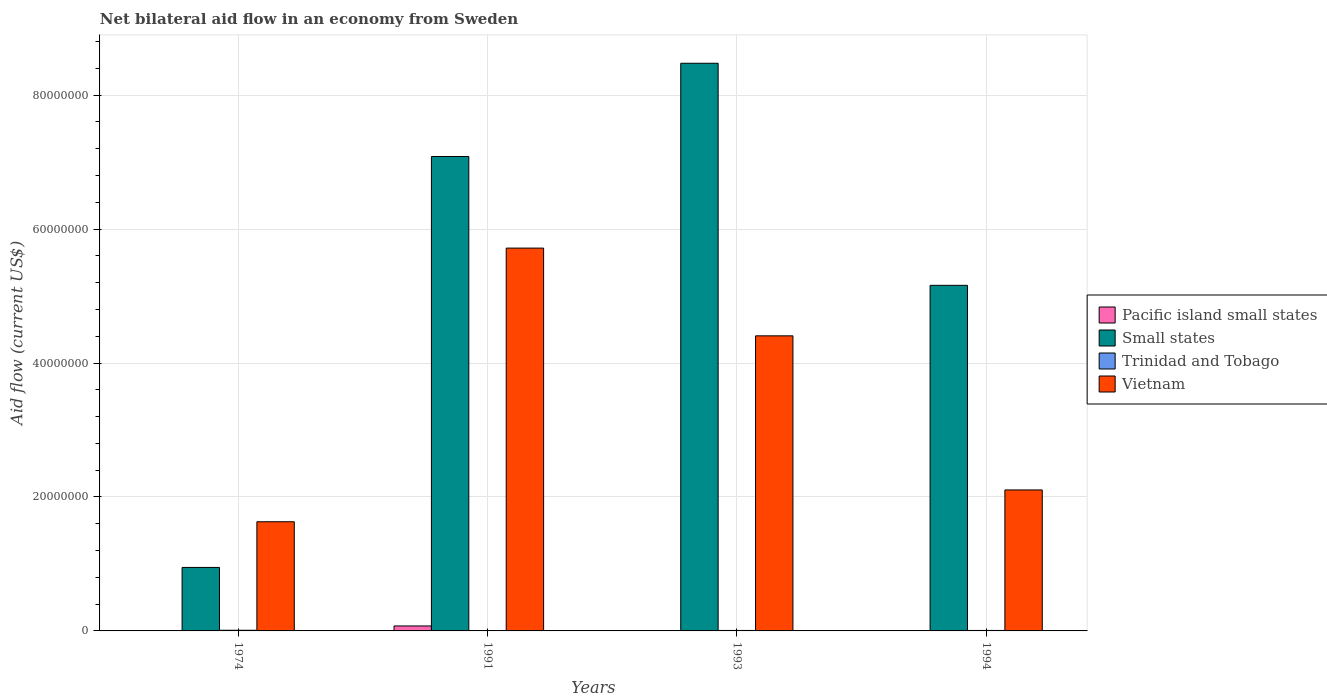How many groups of bars are there?
Your response must be concise. 4. How many bars are there on the 3rd tick from the left?
Your response must be concise. 4. What is the label of the 4th group of bars from the left?
Your answer should be very brief. 1994. Across all years, what is the maximum net bilateral aid flow in Small states?
Keep it short and to the point. 8.48e+07. Across all years, what is the minimum net bilateral aid flow in Pacific island small states?
Give a very brief answer. 2.00e+04. In which year was the net bilateral aid flow in Small states minimum?
Keep it short and to the point. 1974. What is the total net bilateral aid flow in Pacific island small states in the graph?
Ensure brevity in your answer.  8.50e+05. What is the difference between the net bilateral aid flow in Vietnam in 1974 and that in 1991?
Provide a short and direct response. -4.09e+07. What is the difference between the net bilateral aid flow in Small states in 1993 and the net bilateral aid flow in Vietnam in 1991?
Provide a short and direct response. 2.76e+07. What is the average net bilateral aid flow in Vietnam per year?
Ensure brevity in your answer.  3.46e+07. In the year 1974, what is the difference between the net bilateral aid flow in Pacific island small states and net bilateral aid flow in Trinidad and Tobago?
Give a very brief answer. -6.00e+04. What is the ratio of the net bilateral aid flow in Vietnam in 1991 to that in 1993?
Provide a short and direct response. 1.3. Is the net bilateral aid flow in Pacific island small states in 1991 less than that in 1993?
Keep it short and to the point. No. What is the difference between the highest and the second highest net bilateral aid flow in Pacific island small states?
Make the answer very short. 6.90e+05. What is the difference between the highest and the lowest net bilateral aid flow in Pacific island small states?
Your answer should be compact. 7.20e+05. What does the 1st bar from the left in 1974 represents?
Offer a very short reply. Pacific island small states. What does the 1st bar from the right in 1991 represents?
Offer a terse response. Vietnam. Is it the case that in every year, the sum of the net bilateral aid flow in Small states and net bilateral aid flow in Pacific island small states is greater than the net bilateral aid flow in Vietnam?
Offer a terse response. No. Are all the bars in the graph horizontal?
Keep it short and to the point. No. What is the difference between two consecutive major ticks on the Y-axis?
Provide a succinct answer. 2.00e+07. Are the values on the major ticks of Y-axis written in scientific E-notation?
Offer a very short reply. No. How many legend labels are there?
Ensure brevity in your answer.  4. What is the title of the graph?
Give a very brief answer. Net bilateral aid flow in an economy from Sweden. What is the label or title of the X-axis?
Offer a very short reply. Years. What is the Aid flow (current US$) of Pacific island small states in 1974?
Make the answer very short. 4.00e+04. What is the Aid flow (current US$) of Small states in 1974?
Your answer should be compact. 9.48e+06. What is the Aid flow (current US$) of Vietnam in 1974?
Keep it short and to the point. 1.63e+07. What is the Aid flow (current US$) of Pacific island small states in 1991?
Keep it short and to the point. 7.40e+05. What is the Aid flow (current US$) of Small states in 1991?
Give a very brief answer. 7.08e+07. What is the Aid flow (current US$) of Trinidad and Tobago in 1991?
Make the answer very short. 3.00e+04. What is the Aid flow (current US$) of Vietnam in 1991?
Your answer should be very brief. 5.72e+07. What is the Aid flow (current US$) of Pacific island small states in 1993?
Your answer should be compact. 5.00e+04. What is the Aid flow (current US$) of Small states in 1993?
Your answer should be compact. 8.48e+07. What is the Aid flow (current US$) in Trinidad and Tobago in 1993?
Your answer should be compact. 7.00e+04. What is the Aid flow (current US$) in Vietnam in 1993?
Keep it short and to the point. 4.41e+07. What is the Aid flow (current US$) of Small states in 1994?
Your response must be concise. 5.16e+07. What is the Aid flow (current US$) of Trinidad and Tobago in 1994?
Offer a very short reply. 7.00e+04. What is the Aid flow (current US$) in Vietnam in 1994?
Offer a terse response. 2.10e+07. Across all years, what is the maximum Aid flow (current US$) of Pacific island small states?
Offer a terse response. 7.40e+05. Across all years, what is the maximum Aid flow (current US$) in Small states?
Ensure brevity in your answer.  8.48e+07. Across all years, what is the maximum Aid flow (current US$) of Vietnam?
Your answer should be very brief. 5.72e+07. Across all years, what is the minimum Aid flow (current US$) in Small states?
Offer a very short reply. 9.48e+06. Across all years, what is the minimum Aid flow (current US$) of Trinidad and Tobago?
Provide a short and direct response. 3.00e+04. Across all years, what is the minimum Aid flow (current US$) in Vietnam?
Your answer should be very brief. 1.63e+07. What is the total Aid flow (current US$) in Pacific island small states in the graph?
Give a very brief answer. 8.50e+05. What is the total Aid flow (current US$) in Small states in the graph?
Provide a succinct answer. 2.17e+08. What is the total Aid flow (current US$) in Trinidad and Tobago in the graph?
Your response must be concise. 2.70e+05. What is the total Aid flow (current US$) in Vietnam in the graph?
Ensure brevity in your answer.  1.39e+08. What is the difference between the Aid flow (current US$) of Pacific island small states in 1974 and that in 1991?
Your answer should be compact. -7.00e+05. What is the difference between the Aid flow (current US$) of Small states in 1974 and that in 1991?
Provide a succinct answer. -6.14e+07. What is the difference between the Aid flow (current US$) in Vietnam in 1974 and that in 1991?
Provide a short and direct response. -4.09e+07. What is the difference between the Aid flow (current US$) of Small states in 1974 and that in 1993?
Provide a succinct answer. -7.53e+07. What is the difference between the Aid flow (current US$) of Vietnam in 1974 and that in 1993?
Make the answer very short. -2.78e+07. What is the difference between the Aid flow (current US$) in Small states in 1974 and that in 1994?
Your answer should be very brief. -4.21e+07. What is the difference between the Aid flow (current US$) of Vietnam in 1974 and that in 1994?
Give a very brief answer. -4.75e+06. What is the difference between the Aid flow (current US$) of Pacific island small states in 1991 and that in 1993?
Your response must be concise. 6.90e+05. What is the difference between the Aid flow (current US$) in Small states in 1991 and that in 1993?
Provide a short and direct response. -1.39e+07. What is the difference between the Aid flow (current US$) of Trinidad and Tobago in 1991 and that in 1993?
Provide a succinct answer. -4.00e+04. What is the difference between the Aid flow (current US$) of Vietnam in 1991 and that in 1993?
Your response must be concise. 1.31e+07. What is the difference between the Aid flow (current US$) in Pacific island small states in 1991 and that in 1994?
Provide a short and direct response. 7.20e+05. What is the difference between the Aid flow (current US$) in Small states in 1991 and that in 1994?
Make the answer very short. 1.92e+07. What is the difference between the Aid flow (current US$) of Vietnam in 1991 and that in 1994?
Provide a short and direct response. 3.61e+07. What is the difference between the Aid flow (current US$) in Small states in 1993 and that in 1994?
Provide a succinct answer. 3.32e+07. What is the difference between the Aid flow (current US$) in Vietnam in 1993 and that in 1994?
Your answer should be very brief. 2.30e+07. What is the difference between the Aid flow (current US$) in Pacific island small states in 1974 and the Aid flow (current US$) in Small states in 1991?
Ensure brevity in your answer.  -7.08e+07. What is the difference between the Aid flow (current US$) in Pacific island small states in 1974 and the Aid flow (current US$) in Trinidad and Tobago in 1991?
Offer a very short reply. 10000. What is the difference between the Aid flow (current US$) of Pacific island small states in 1974 and the Aid flow (current US$) of Vietnam in 1991?
Offer a terse response. -5.71e+07. What is the difference between the Aid flow (current US$) in Small states in 1974 and the Aid flow (current US$) in Trinidad and Tobago in 1991?
Ensure brevity in your answer.  9.45e+06. What is the difference between the Aid flow (current US$) of Small states in 1974 and the Aid flow (current US$) of Vietnam in 1991?
Provide a short and direct response. -4.77e+07. What is the difference between the Aid flow (current US$) of Trinidad and Tobago in 1974 and the Aid flow (current US$) of Vietnam in 1991?
Offer a very short reply. -5.71e+07. What is the difference between the Aid flow (current US$) in Pacific island small states in 1974 and the Aid flow (current US$) in Small states in 1993?
Your answer should be very brief. -8.47e+07. What is the difference between the Aid flow (current US$) of Pacific island small states in 1974 and the Aid flow (current US$) of Trinidad and Tobago in 1993?
Keep it short and to the point. -3.00e+04. What is the difference between the Aid flow (current US$) in Pacific island small states in 1974 and the Aid flow (current US$) in Vietnam in 1993?
Your answer should be compact. -4.40e+07. What is the difference between the Aid flow (current US$) of Small states in 1974 and the Aid flow (current US$) of Trinidad and Tobago in 1993?
Keep it short and to the point. 9.41e+06. What is the difference between the Aid flow (current US$) of Small states in 1974 and the Aid flow (current US$) of Vietnam in 1993?
Ensure brevity in your answer.  -3.46e+07. What is the difference between the Aid flow (current US$) of Trinidad and Tobago in 1974 and the Aid flow (current US$) of Vietnam in 1993?
Give a very brief answer. -4.40e+07. What is the difference between the Aid flow (current US$) in Pacific island small states in 1974 and the Aid flow (current US$) in Small states in 1994?
Provide a succinct answer. -5.16e+07. What is the difference between the Aid flow (current US$) in Pacific island small states in 1974 and the Aid flow (current US$) in Vietnam in 1994?
Your answer should be compact. -2.10e+07. What is the difference between the Aid flow (current US$) of Small states in 1974 and the Aid flow (current US$) of Trinidad and Tobago in 1994?
Keep it short and to the point. 9.41e+06. What is the difference between the Aid flow (current US$) of Small states in 1974 and the Aid flow (current US$) of Vietnam in 1994?
Offer a very short reply. -1.16e+07. What is the difference between the Aid flow (current US$) of Trinidad and Tobago in 1974 and the Aid flow (current US$) of Vietnam in 1994?
Keep it short and to the point. -2.10e+07. What is the difference between the Aid flow (current US$) of Pacific island small states in 1991 and the Aid flow (current US$) of Small states in 1993?
Your answer should be very brief. -8.40e+07. What is the difference between the Aid flow (current US$) in Pacific island small states in 1991 and the Aid flow (current US$) in Trinidad and Tobago in 1993?
Provide a succinct answer. 6.70e+05. What is the difference between the Aid flow (current US$) of Pacific island small states in 1991 and the Aid flow (current US$) of Vietnam in 1993?
Ensure brevity in your answer.  -4.33e+07. What is the difference between the Aid flow (current US$) of Small states in 1991 and the Aid flow (current US$) of Trinidad and Tobago in 1993?
Make the answer very short. 7.08e+07. What is the difference between the Aid flow (current US$) in Small states in 1991 and the Aid flow (current US$) in Vietnam in 1993?
Your answer should be compact. 2.68e+07. What is the difference between the Aid flow (current US$) in Trinidad and Tobago in 1991 and the Aid flow (current US$) in Vietnam in 1993?
Your answer should be very brief. -4.40e+07. What is the difference between the Aid flow (current US$) of Pacific island small states in 1991 and the Aid flow (current US$) of Small states in 1994?
Offer a very short reply. -5.09e+07. What is the difference between the Aid flow (current US$) of Pacific island small states in 1991 and the Aid flow (current US$) of Trinidad and Tobago in 1994?
Offer a very short reply. 6.70e+05. What is the difference between the Aid flow (current US$) in Pacific island small states in 1991 and the Aid flow (current US$) in Vietnam in 1994?
Ensure brevity in your answer.  -2.03e+07. What is the difference between the Aid flow (current US$) in Small states in 1991 and the Aid flow (current US$) in Trinidad and Tobago in 1994?
Give a very brief answer. 7.08e+07. What is the difference between the Aid flow (current US$) in Small states in 1991 and the Aid flow (current US$) in Vietnam in 1994?
Make the answer very short. 4.98e+07. What is the difference between the Aid flow (current US$) in Trinidad and Tobago in 1991 and the Aid flow (current US$) in Vietnam in 1994?
Provide a short and direct response. -2.10e+07. What is the difference between the Aid flow (current US$) in Pacific island small states in 1993 and the Aid flow (current US$) in Small states in 1994?
Keep it short and to the point. -5.16e+07. What is the difference between the Aid flow (current US$) in Pacific island small states in 1993 and the Aid flow (current US$) in Vietnam in 1994?
Offer a terse response. -2.10e+07. What is the difference between the Aid flow (current US$) of Small states in 1993 and the Aid flow (current US$) of Trinidad and Tobago in 1994?
Provide a short and direct response. 8.47e+07. What is the difference between the Aid flow (current US$) in Small states in 1993 and the Aid flow (current US$) in Vietnam in 1994?
Offer a terse response. 6.37e+07. What is the difference between the Aid flow (current US$) in Trinidad and Tobago in 1993 and the Aid flow (current US$) in Vietnam in 1994?
Provide a succinct answer. -2.10e+07. What is the average Aid flow (current US$) of Pacific island small states per year?
Offer a very short reply. 2.12e+05. What is the average Aid flow (current US$) of Small states per year?
Provide a succinct answer. 5.42e+07. What is the average Aid flow (current US$) in Trinidad and Tobago per year?
Make the answer very short. 6.75e+04. What is the average Aid flow (current US$) of Vietnam per year?
Make the answer very short. 3.46e+07. In the year 1974, what is the difference between the Aid flow (current US$) of Pacific island small states and Aid flow (current US$) of Small states?
Keep it short and to the point. -9.44e+06. In the year 1974, what is the difference between the Aid flow (current US$) of Pacific island small states and Aid flow (current US$) of Vietnam?
Give a very brief answer. -1.63e+07. In the year 1974, what is the difference between the Aid flow (current US$) in Small states and Aid flow (current US$) in Trinidad and Tobago?
Your response must be concise. 9.38e+06. In the year 1974, what is the difference between the Aid flow (current US$) in Small states and Aid flow (current US$) in Vietnam?
Provide a succinct answer. -6.82e+06. In the year 1974, what is the difference between the Aid flow (current US$) of Trinidad and Tobago and Aid flow (current US$) of Vietnam?
Your response must be concise. -1.62e+07. In the year 1991, what is the difference between the Aid flow (current US$) of Pacific island small states and Aid flow (current US$) of Small states?
Keep it short and to the point. -7.01e+07. In the year 1991, what is the difference between the Aid flow (current US$) of Pacific island small states and Aid flow (current US$) of Trinidad and Tobago?
Your answer should be compact. 7.10e+05. In the year 1991, what is the difference between the Aid flow (current US$) in Pacific island small states and Aid flow (current US$) in Vietnam?
Give a very brief answer. -5.64e+07. In the year 1991, what is the difference between the Aid flow (current US$) in Small states and Aid flow (current US$) in Trinidad and Tobago?
Provide a short and direct response. 7.08e+07. In the year 1991, what is the difference between the Aid flow (current US$) in Small states and Aid flow (current US$) in Vietnam?
Ensure brevity in your answer.  1.37e+07. In the year 1991, what is the difference between the Aid flow (current US$) in Trinidad and Tobago and Aid flow (current US$) in Vietnam?
Make the answer very short. -5.71e+07. In the year 1993, what is the difference between the Aid flow (current US$) of Pacific island small states and Aid flow (current US$) of Small states?
Give a very brief answer. -8.47e+07. In the year 1993, what is the difference between the Aid flow (current US$) of Pacific island small states and Aid flow (current US$) of Vietnam?
Your response must be concise. -4.40e+07. In the year 1993, what is the difference between the Aid flow (current US$) in Small states and Aid flow (current US$) in Trinidad and Tobago?
Offer a very short reply. 8.47e+07. In the year 1993, what is the difference between the Aid flow (current US$) of Small states and Aid flow (current US$) of Vietnam?
Your answer should be very brief. 4.07e+07. In the year 1993, what is the difference between the Aid flow (current US$) in Trinidad and Tobago and Aid flow (current US$) in Vietnam?
Keep it short and to the point. -4.40e+07. In the year 1994, what is the difference between the Aid flow (current US$) of Pacific island small states and Aid flow (current US$) of Small states?
Provide a short and direct response. -5.16e+07. In the year 1994, what is the difference between the Aid flow (current US$) in Pacific island small states and Aid flow (current US$) in Trinidad and Tobago?
Make the answer very short. -5.00e+04. In the year 1994, what is the difference between the Aid flow (current US$) in Pacific island small states and Aid flow (current US$) in Vietnam?
Offer a terse response. -2.10e+07. In the year 1994, what is the difference between the Aid flow (current US$) of Small states and Aid flow (current US$) of Trinidad and Tobago?
Provide a short and direct response. 5.15e+07. In the year 1994, what is the difference between the Aid flow (current US$) in Small states and Aid flow (current US$) in Vietnam?
Your answer should be very brief. 3.06e+07. In the year 1994, what is the difference between the Aid flow (current US$) in Trinidad and Tobago and Aid flow (current US$) in Vietnam?
Provide a succinct answer. -2.10e+07. What is the ratio of the Aid flow (current US$) of Pacific island small states in 1974 to that in 1991?
Make the answer very short. 0.05. What is the ratio of the Aid flow (current US$) of Small states in 1974 to that in 1991?
Your response must be concise. 0.13. What is the ratio of the Aid flow (current US$) of Trinidad and Tobago in 1974 to that in 1991?
Give a very brief answer. 3.33. What is the ratio of the Aid flow (current US$) of Vietnam in 1974 to that in 1991?
Your answer should be compact. 0.29. What is the ratio of the Aid flow (current US$) of Small states in 1974 to that in 1993?
Give a very brief answer. 0.11. What is the ratio of the Aid flow (current US$) of Trinidad and Tobago in 1974 to that in 1993?
Your answer should be very brief. 1.43. What is the ratio of the Aid flow (current US$) of Vietnam in 1974 to that in 1993?
Give a very brief answer. 0.37. What is the ratio of the Aid flow (current US$) of Pacific island small states in 1974 to that in 1994?
Offer a terse response. 2. What is the ratio of the Aid flow (current US$) of Small states in 1974 to that in 1994?
Provide a succinct answer. 0.18. What is the ratio of the Aid flow (current US$) in Trinidad and Tobago in 1974 to that in 1994?
Keep it short and to the point. 1.43. What is the ratio of the Aid flow (current US$) of Vietnam in 1974 to that in 1994?
Offer a terse response. 0.77. What is the ratio of the Aid flow (current US$) in Small states in 1991 to that in 1993?
Provide a short and direct response. 0.84. What is the ratio of the Aid flow (current US$) in Trinidad and Tobago in 1991 to that in 1993?
Your answer should be very brief. 0.43. What is the ratio of the Aid flow (current US$) of Vietnam in 1991 to that in 1993?
Give a very brief answer. 1.3. What is the ratio of the Aid flow (current US$) of Pacific island small states in 1991 to that in 1994?
Ensure brevity in your answer.  37. What is the ratio of the Aid flow (current US$) in Small states in 1991 to that in 1994?
Provide a succinct answer. 1.37. What is the ratio of the Aid flow (current US$) of Trinidad and Tobago in 1991 to that in 1994?
Provide a succinct answer. 0.43. What is the ratio of the Aid flow (current US$) of Vietnam in 1991 to that in 1994?
Offer a terse response. 2.72. What is the ratio of the Aid flow (current US$) in Small states in 1993 to that in 1994?
Your response must be concise. 1.64. What is the ratio of the Aid flow (current US$) of Trinidad and Tobago in 1993 to that in 1994?
Make the answer very short. 1. What is the ratio of the Aid flow (current US$) in Vietnam in 1993 to that in 1994?
Make the answer very short. 2.09. What is the difference between the highest and the second highest Aid flow (current US$) in Pacific island small states?
Keep it short and to the point. 6.90e+05. What is the difference between the highest and the second highest Aid flow (current US$) in Small states?
Give a very brief answer. 1.39e+07. What is the difference between the highest and the second highest Aid flow (current US$) of Trinidad and Tobago?
Your answer should be compact. 3.00e+04. What is the difference between the highest and the second highest Aid flow (current US$) of Vietnam?
Offer a terse response. 1.31e+07. What is the difference between the highest and the lowest Aid flow (current US$) of Pacific island small states?
Keep it short and to the point. 7.20e+05. What is the difference between the highest and the lowest Aid flow (current US$) in Small states?
Make the answer very short. 7.53e+07. What is the difference between the highest and the lowest Aid flow (current US$) in Trinidad and Tobago?
Your answer should be very brief. 7.00e+04. What is the difference between the highest and the lowest Aid flow (current US$) of Vietnam?
Keep it short and to the point. 4.09e+07. 